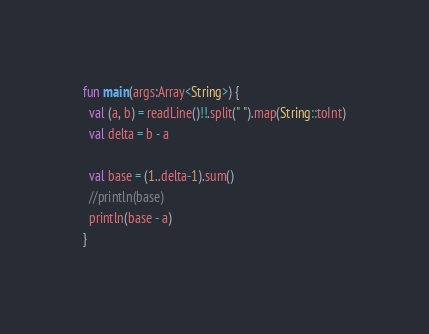<code> <loc_0><loc_0><loc_500><loc_500><_Kotlin_>fun main(args:Array<String>) {
  val (a, b) = readLine()!!.split(" ").map(String::toInt)
  val delta = b - a

  val base = (1..delta-1).sum()
  //println(base)
  println(base - a)
}</code> 